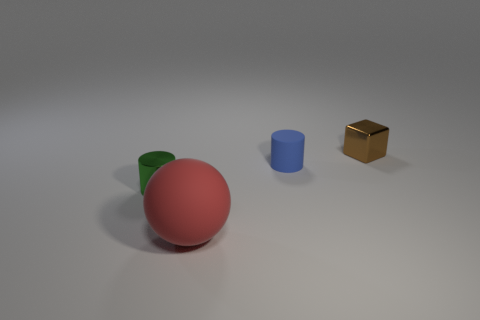Are there any other things that have the same size as the matte sphere?
Ensure brevity in your answer.  No. Do the tiny cylinder on the left side of the large red sphere and the ball have the same material?
Provide a succinct answer. No. Are there any blue matte objects that have the same size as the green metallic thing?
Your answer should be very brief. Yes. There is a green object; does it have the same shape as the matte object on the left side of the small rubber cylinder?
Your answer should be very brief. No. There is a small cylinder that is behind the tiny cylinder that is in front of the blue object; is there a small cylinder that is to the left of it?
Give a very brief answer. Yes. How big is the sphere?
Make the answer very short. Large. What number of other things are there of the same color as the large thing?
Give a very brief answer. 0. Do the matte object behind the green metallic object and the tiny green metal object have the same shape?
Your answer should be very brief. Yes. The other object that is the same shape as the blue thing is what color?
Your response must be concise. Green. Is there any other thing that has the same material as the large object?
Your answer should be compact. Yes. 